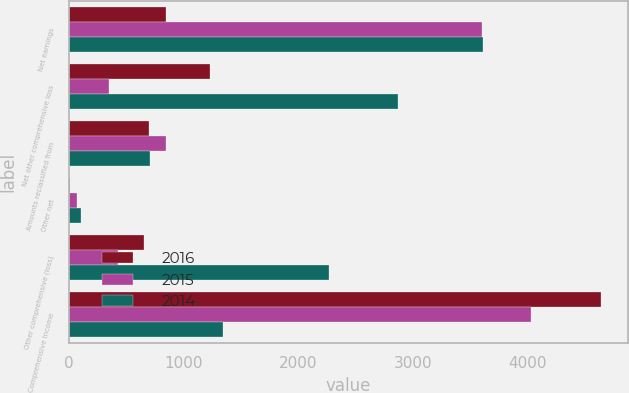Convert chart. <chart><loc_0><loc_0><loc_500><loc_500><stacked_bar_chart><ecel><fcel>Net earnings<fcel>Net other comprehensive loss<fcel>Amounts reclassified from<fcel>Other net<fcel>Other comprehensive (loss)<fcel>Comprehensive income<nl><fcel>2016<fcel>850<fcel>1232<fcel>699<fcel>9<fcel>658<fcel>4644<nl><fcel>2015<fcel>3605<fcel>351<fcel>850<fcel>73<fcel>426<fcel>4031<nl><fcel>2014<fcel>3614<fcel>2870<fcel>706<fcel>105<fcel>2269<fcel>1345<nl></chart> 